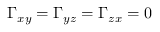Convert formula to latex. <formula><loc_0><loc_0><loc_500><loc_500>\Gamma _ { x y } = \Gamma _ { y z } = \Gamma _ { z x } = 0</formula> 